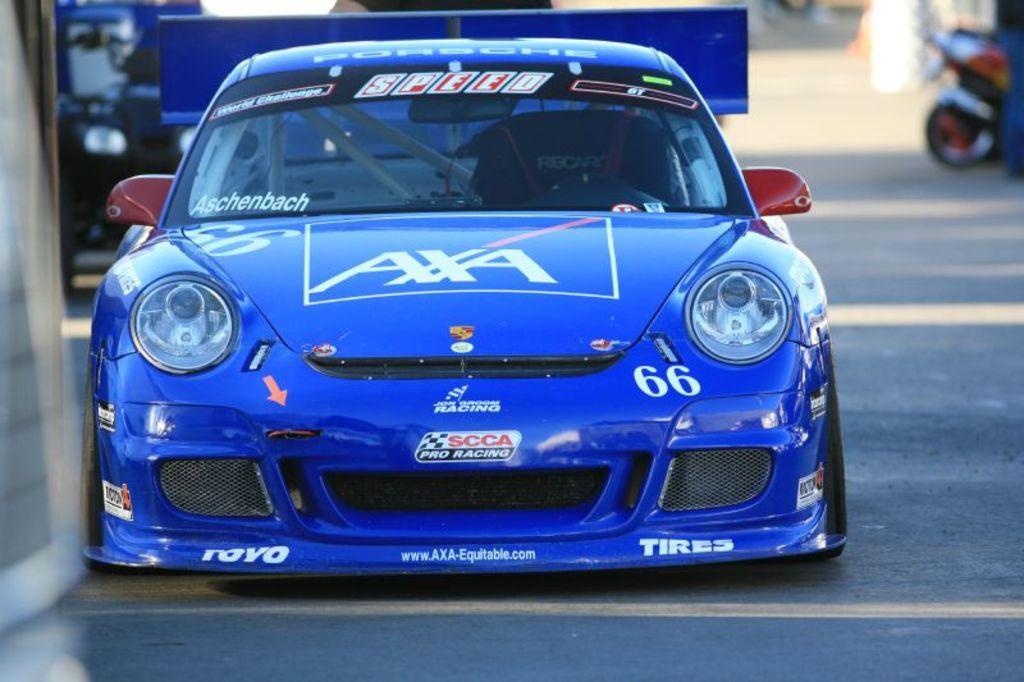Could you give a brief overview of what you see in this image? In this picture we can observe a blue color car on the road. We can observe red color mirrors to this car. On the right side there is a bike parked here. In the background it is completely blur. 